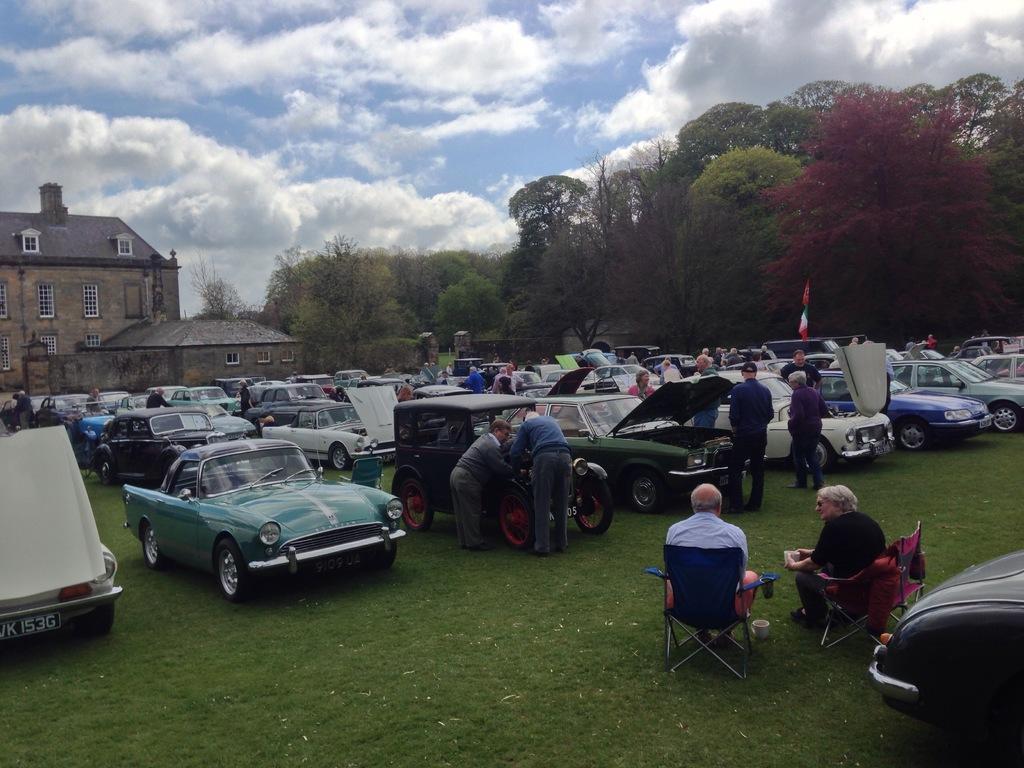Describe this image in one or two sentences. There are people,few people standing and these two people sitting on chairs. We can see vehicles on the grass. In the background we can see building,house,flags,trees and sky with clouds. 